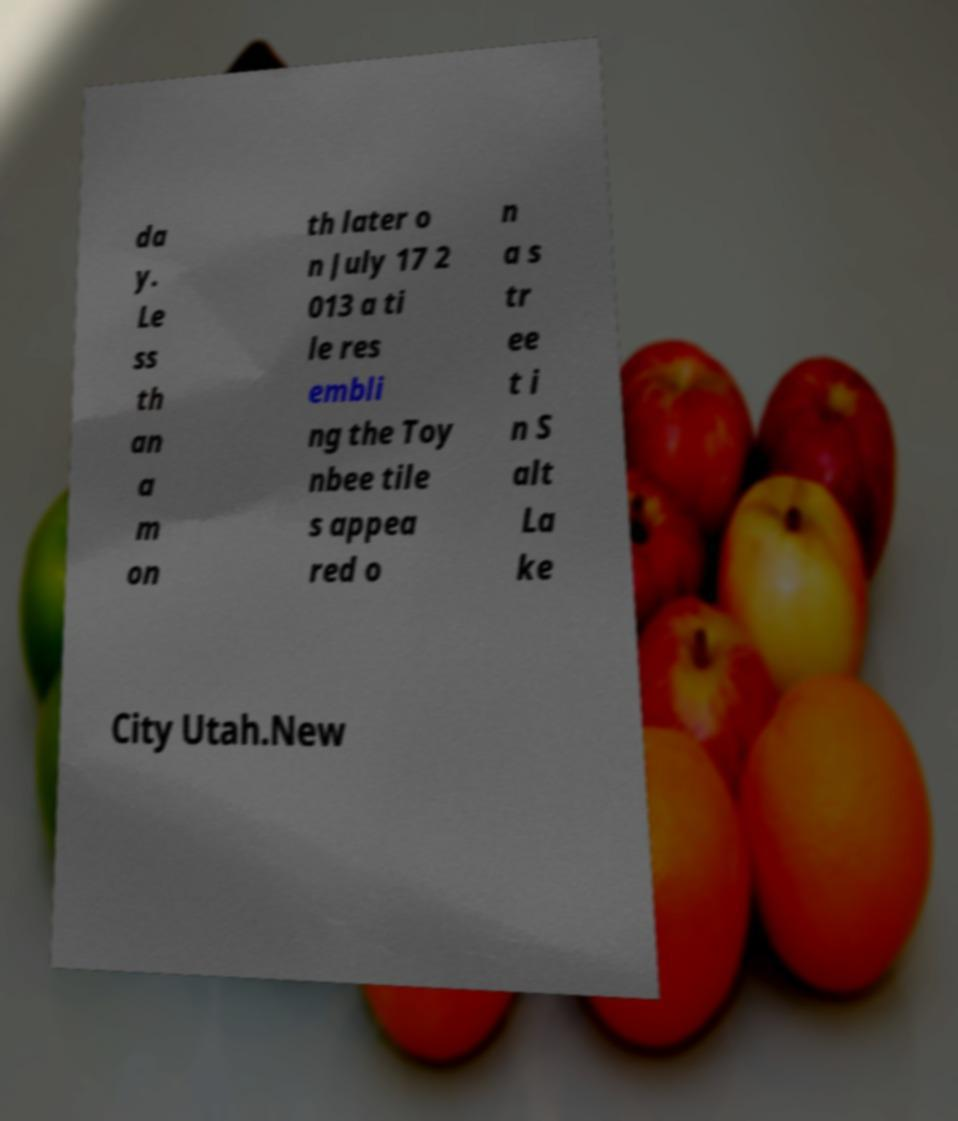Please identify and transcribe the text found in this image. da y. Le ss th an a m on th later o n July 17 2 013 a ti le res embli ng the Toy nbee tile s appea red o n a s tr ee t i n S alt La ke City Utah.New 